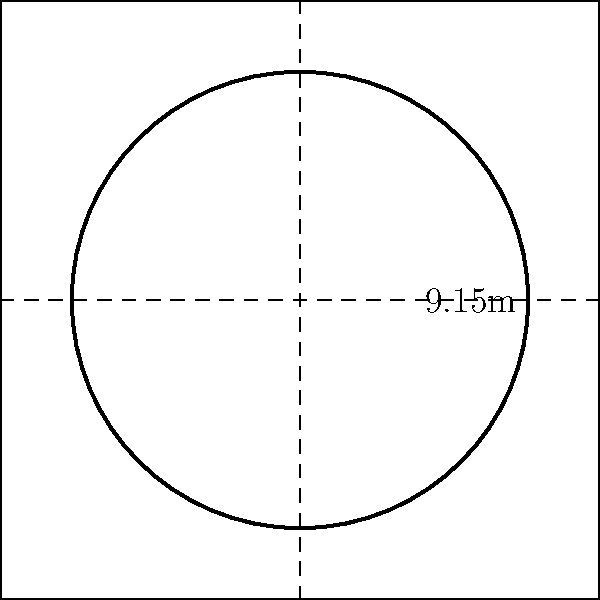As a football fan who appreciates the complexity of a referee's job, you're curious about the pitch dimensions. The circular penalty area has a radius of 9.15 meters. What is the perimeter of this penalty area to the nearest meter? Let's approach this step-by-step:

1) The formula for the circumference (perimeter) of a circle is:
   $$C = 2\pi r$$
   where $C$ is the circumference, $\pi$ is pi, and $r$ is the radius.

2) We're given that the radius is 9.15 meters.

3) Let's substitute this into our formula:
   $$C = 2\pi(9.15)$$

4) $\pi$ is approximately 3.14159. Let's use this value:
   $$C = 2(3.14159)(9.15)$$

5) Let's calculate:
   $$C = 57.49$$

6) Rounding to the nearest meter:
   $$C \approx 57\text{ meters}$$

As a football fan who understands the challenges referees face, you might appreciate that this large perimeter is an area the referee needs to watch closely during the game.
Answer: 57 meters 